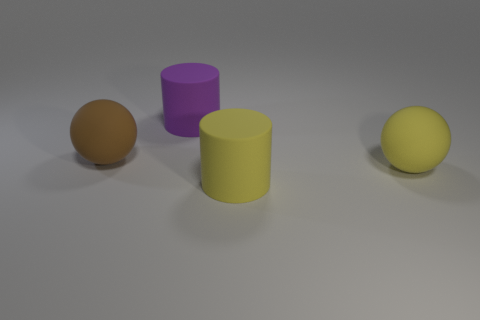The big sphere in front of the big brown thing is what color? yellow 